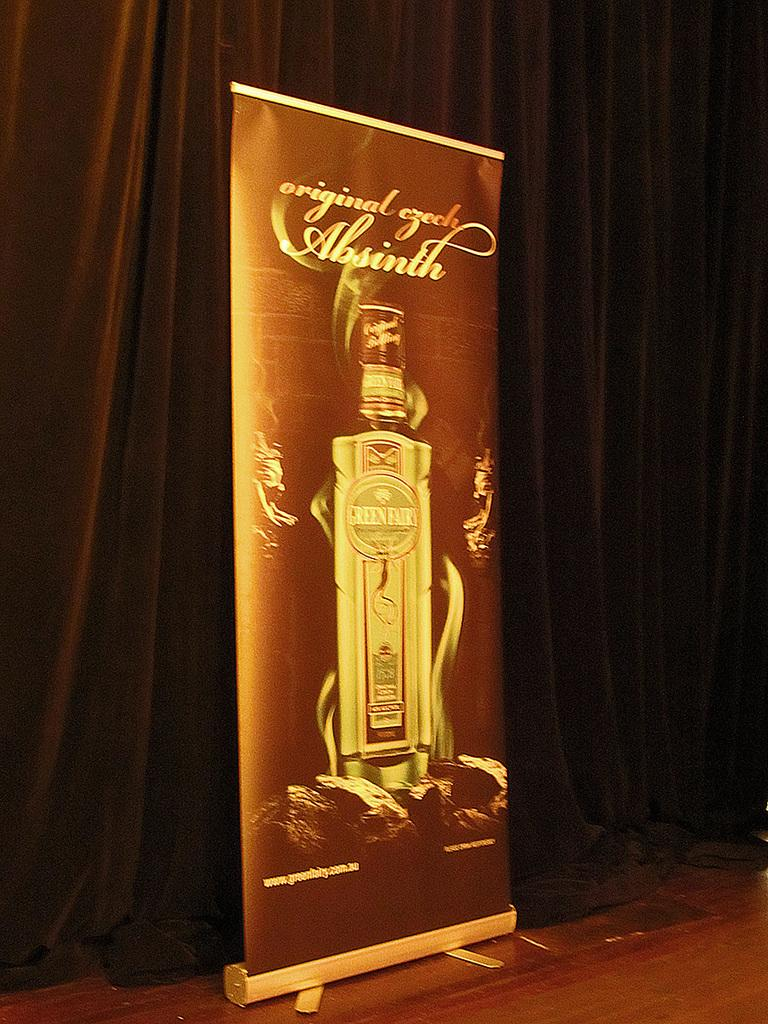<image>
Summarize the visual content of the image. A signboard for Green Fairy is on displayed 